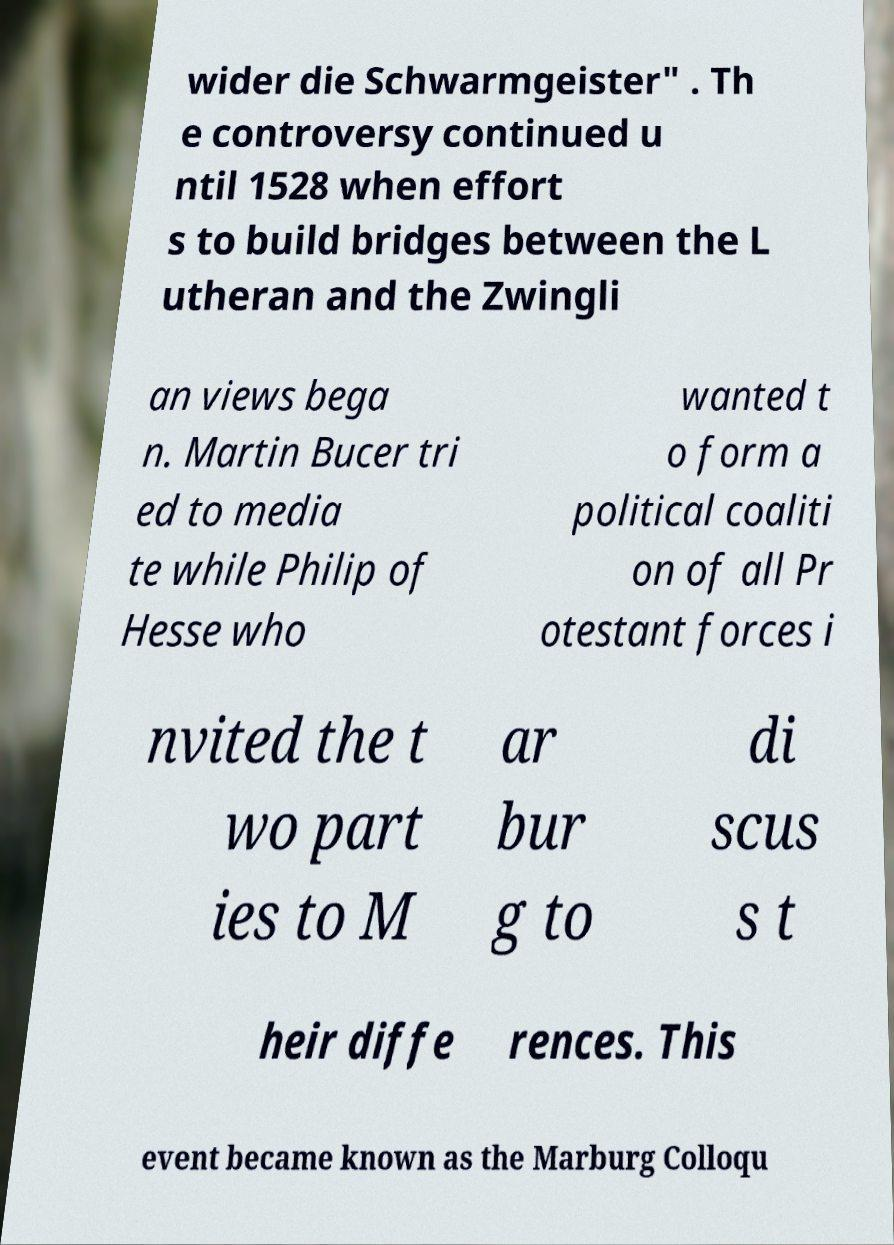Could you extract and type out the text from this image? wider die Schwarmgeister" . Th e controversy continued u ntil 1528 when effort s to build bridges between the L utheran and the Zwingli an views bega n. Martin Bucer tri ed to media te while Philip of Hesse who wanted t o form a political coaliti on of all Pr otestant forces i nvited the t wo part ies to M ar bur g to di scus s t heir diffe rences. This event became known as the Marburg Colloqu 